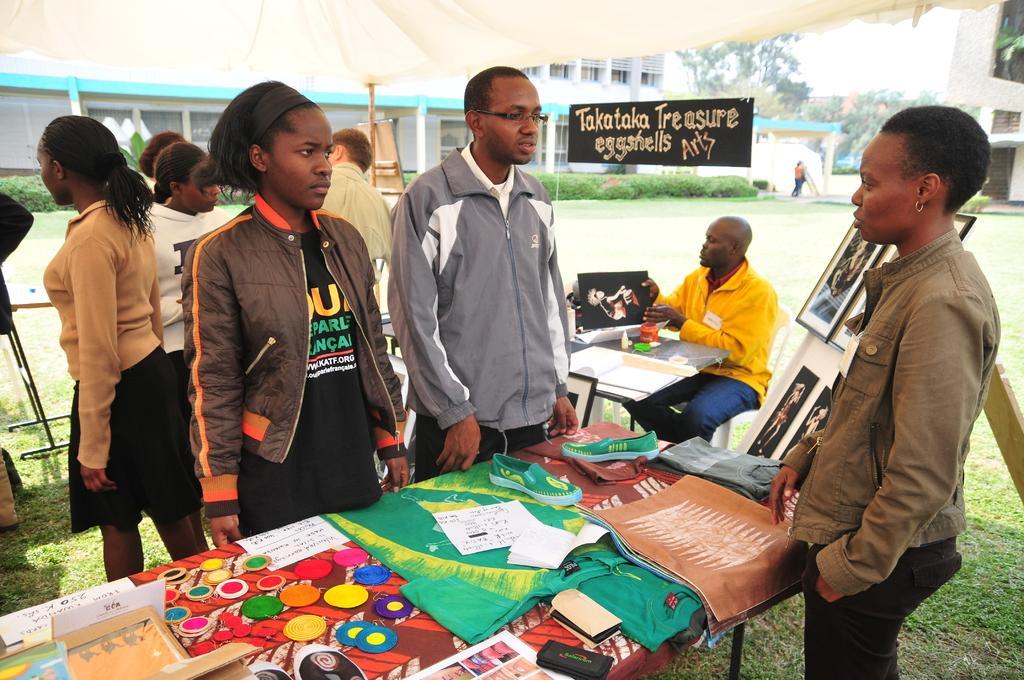Please provide a concise description of this image. In this image I can see in the middle a girl is standing, she wore coat. Beside her a man is also standing, he wore sweater, there are things on this table. Behind them there is a building and on the right side there are bushes. 